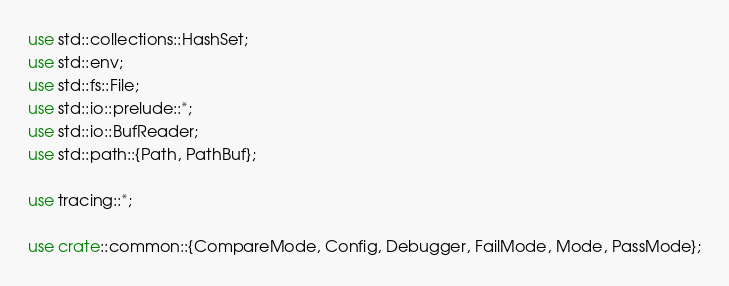Convert code to text. <code><loc_0><loc_0><loc_500><loc_500><_Rust_>use std::collections::HashSet;
use std::env;
use std::fs::File;
use std::io::prelude::*;
use std::io::BufReader;
use std::path::{Path, PathBuf};

use tracing::*;

use crate::common::{CompareMode, Config, Debugger, FailMode, Mode, PassMode};</code> 